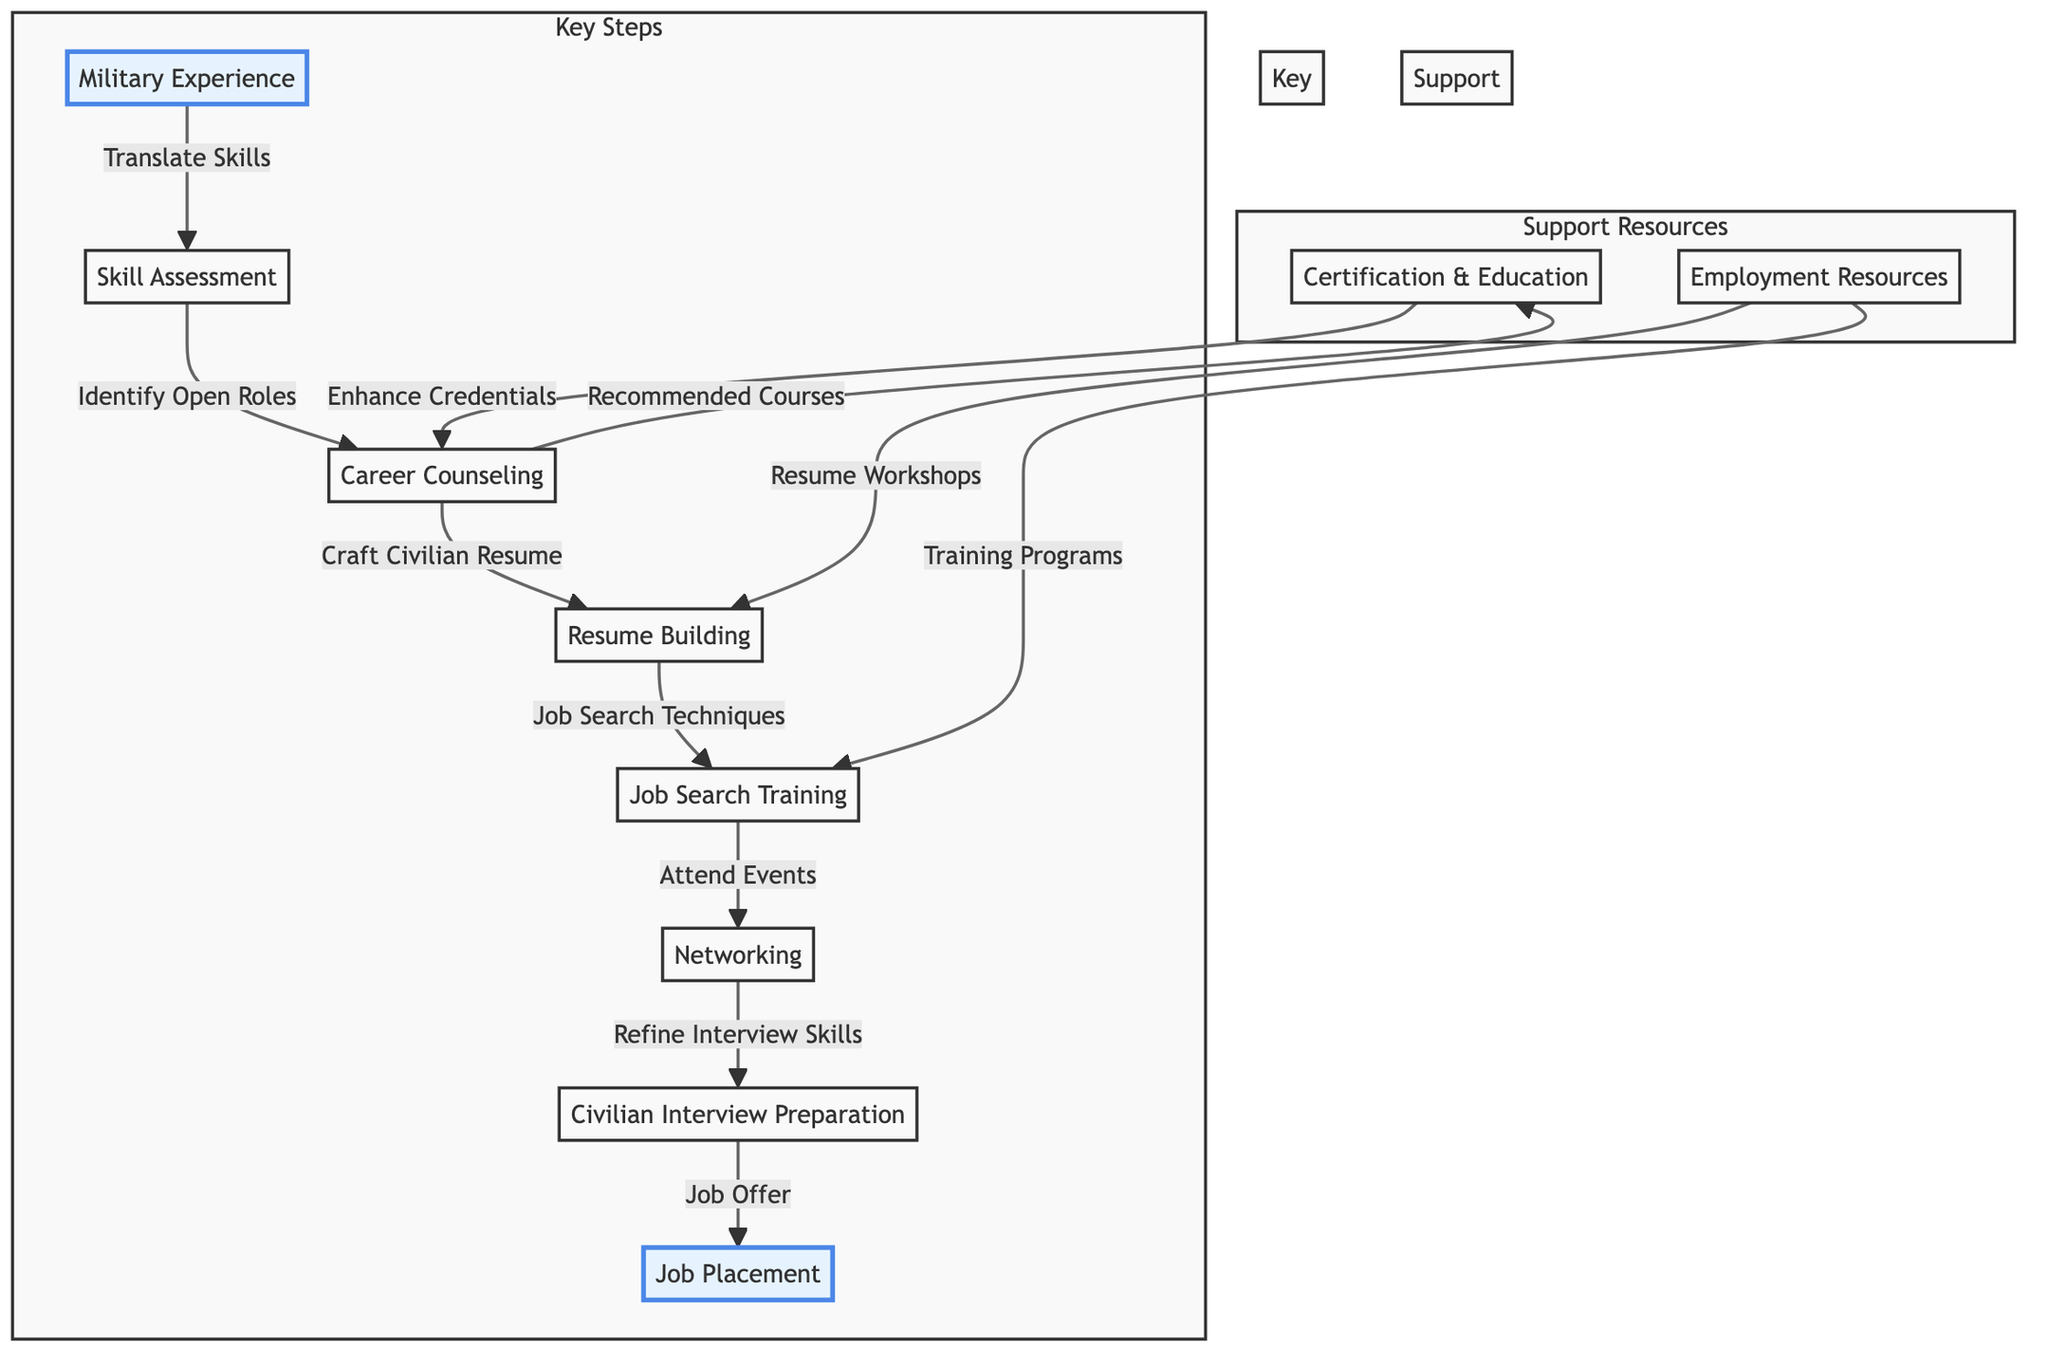What is the starting point of the flowchart? The starting point of the flowchart is represented by the node labeled "Military Experience." This node is the first step from which all other processes flow out.
Answer: Military Experience How many key steps are there in the transition pathway? There are eight key steps outlined in the transition pathway, which include Military Experience, Skill Assessment, Career Counseling, Resume Building, Job Search Training, Networking, Civilian Interview Preparation, and Job Placement.
Answer: Eight What process follows "Skill Assessment"? The process that follows "Skill Assessment" is "Career Counseling." This indicates that after assessing skills, the next step involves counseling for career options.
Answer: Career Counseling What enhances credentials as mentioned in the diagram? The process that enhances credentials is "Certification & Education," which is linked to the node of "Career Counseling." This means obtaining certifications or further education is recommended during counseling.
Answer: Certification & Education What is the result of attending networking events? Attending networking events refines interview skills, as indicated by the arrow from "Networking" to "Civilian Interview Preparation.” This implies that engagement in networking directly contributes to improving interview capabilities.
Answer: Refine Interview Skills How does one improve their resume, according to the diagram? One improves their resume through "Resume Workshops," which are a part of the support resources linked to "Employment Resources." This signifies additional help is available for resume enhancement from workshops.
Answer: Resume Workshops What leads to a job offer? A job offer is a result of being prepared for a civilian interview, as shown by the flow from "Civilian Interview Preparation" to "Job Placement." This indicates the process of interview preparation is critical for receiving a job offer.
Answer: Job Offer Which key step is directly connected to "Networking"? The key step that is directly connected to "Networking" is "Civilian Interview Preparation," suggesting that networking is influential in improving one’s readiness for civilian job interviews.
Answer: Civilian Interview Preparation 